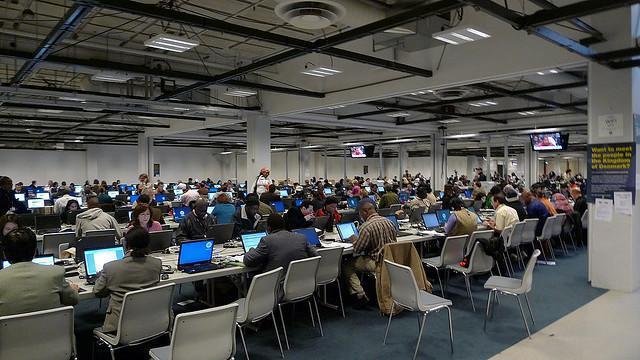How many people are there?
Give a very brief answer. 4. How many chairs can be seen?
Give a very brief answer. 5. 